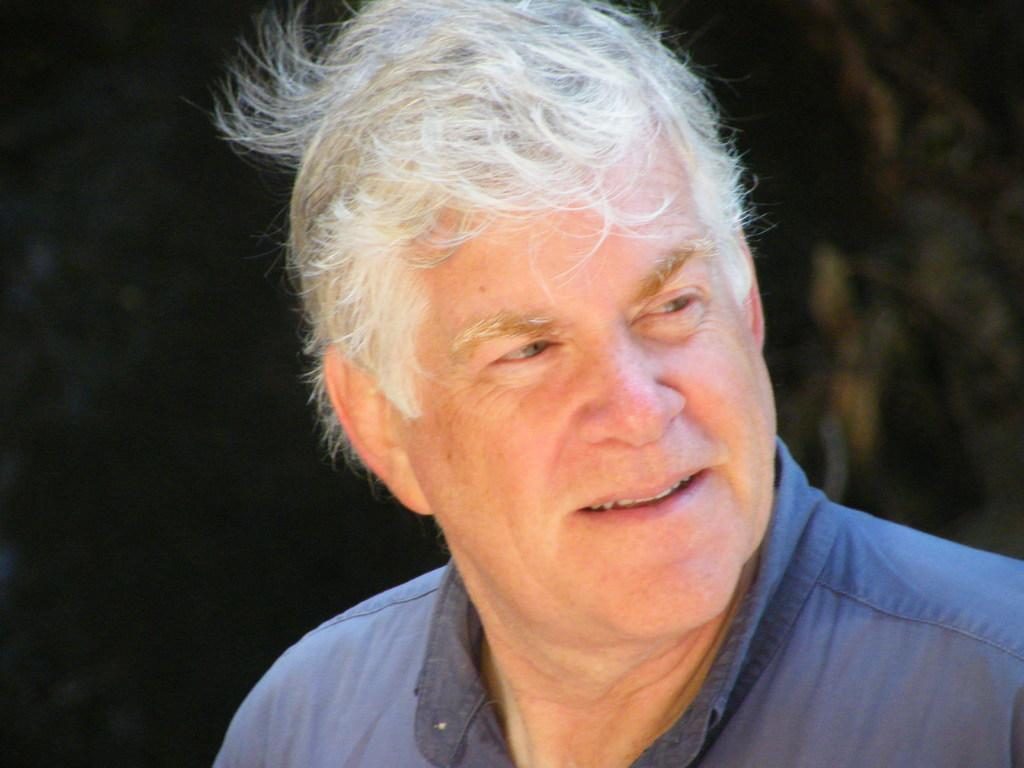Who is present in the image? There is a man in the image. What can be observed about the background of the image? The background of the image is blurred. What type of plant is visible in the image? There is no plant visible in the image. What kind of shoes is the man wearing in the image? The image does not show the man's shoes, so it cannot be determined from the image. 